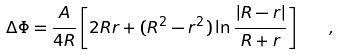Convert formula to latex. <formula><loc_0><loc_0><loc_500><loc_500>\Delta \Phi = \frac { A } { 4 R } \left [ 2 R r + ( R ^ { 2 } - r ^ { 2 } ) \ln \frac { | R - r | } { R + r } \right ] \quad ,</formula> 